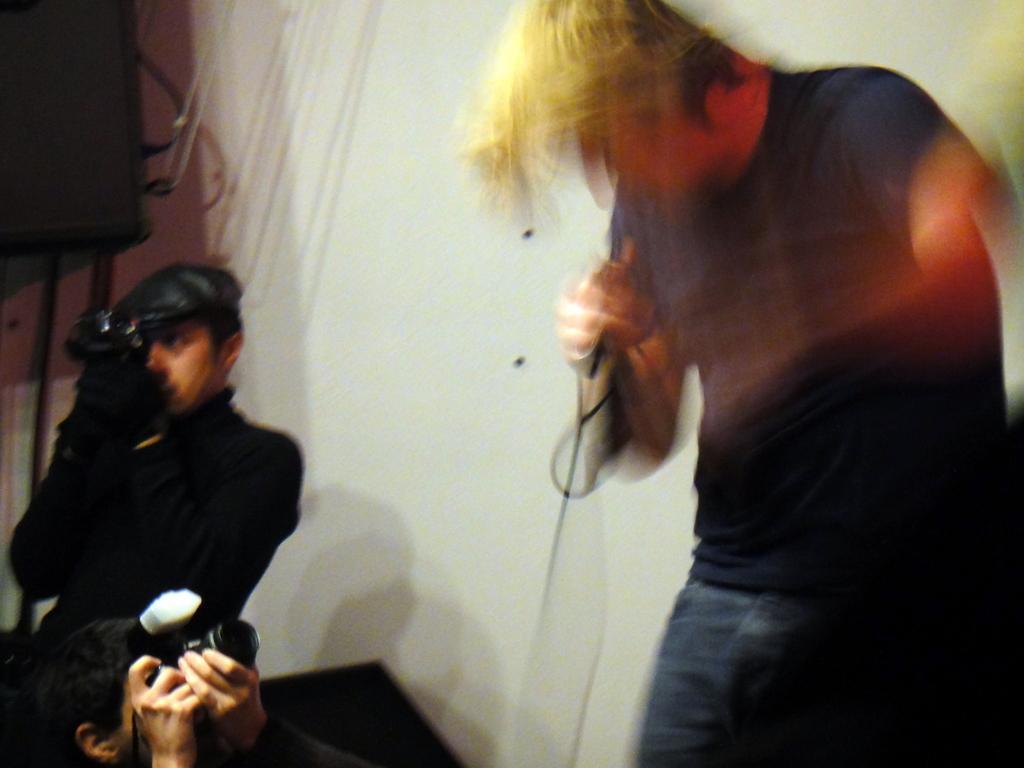Describe this image in one or two sentences. On the right side there is a person holding a mic. It is looking blurred. On the left side two persons are holding camera. Also there is a speaker. In the back there's a wall. And the person on the left side is standing and wearing a cap. 